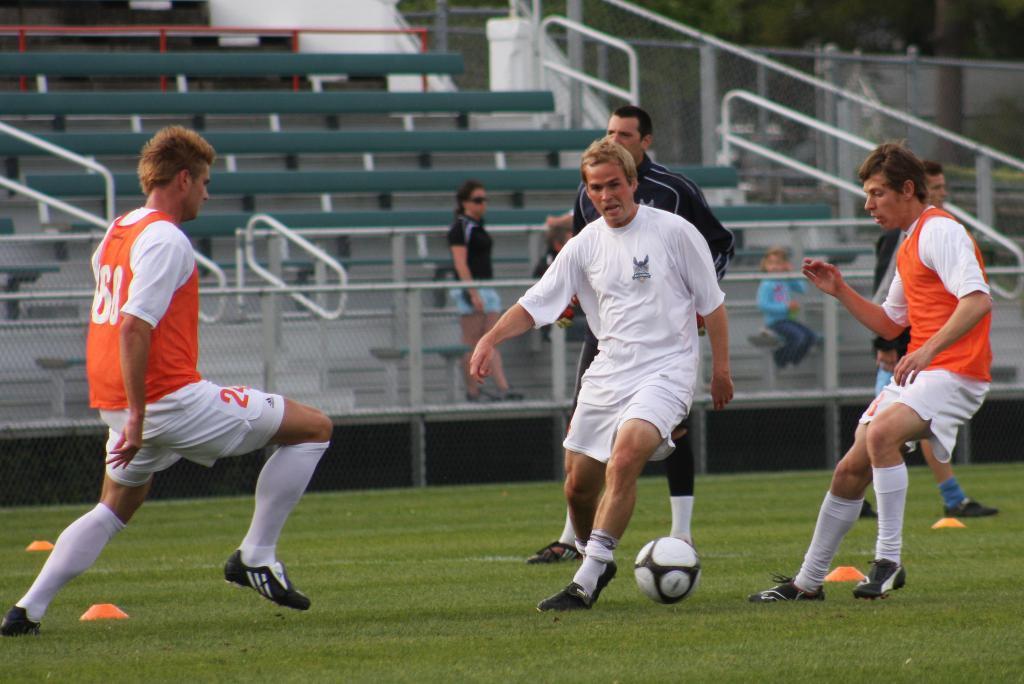Describe this image in one or two sentences. This is the picture of a field on which there are three sports people playing with a ball. 